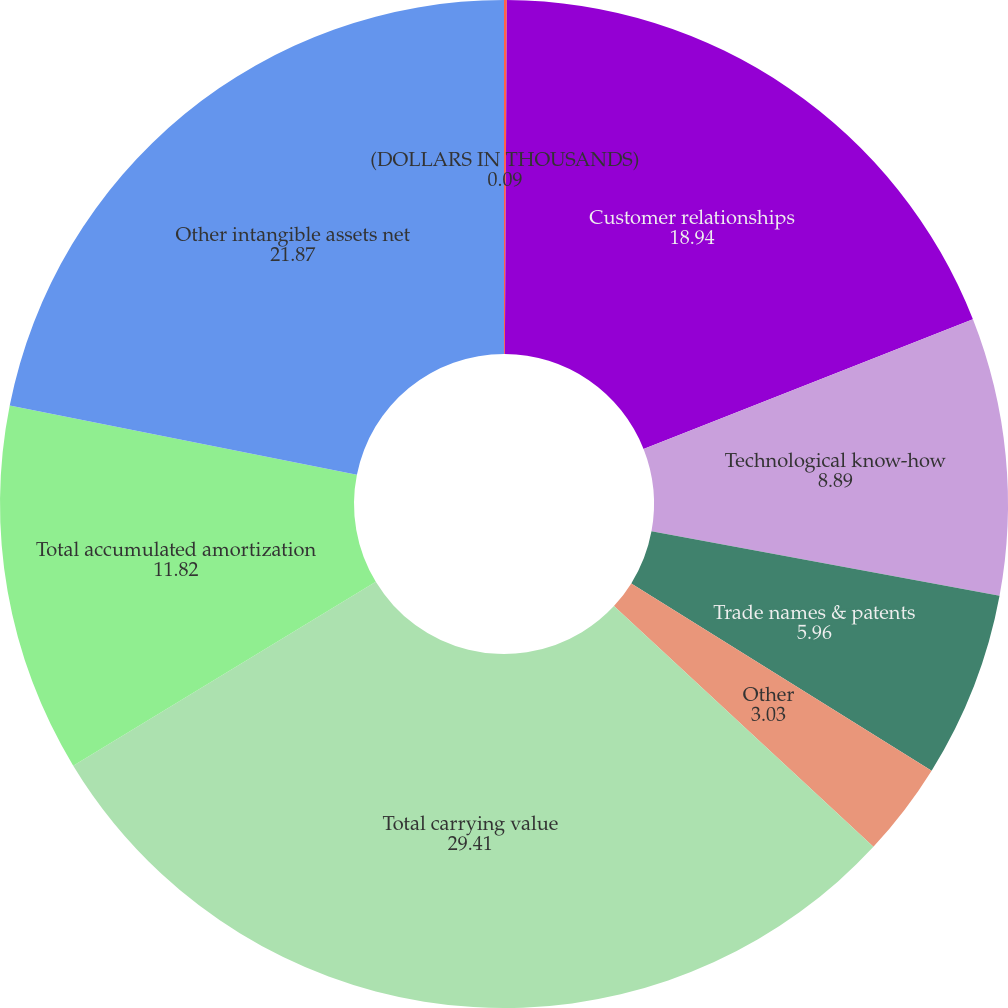Convert chart. <chart><loc_0><loc_0><loc_500><loc_500><pie_chart><fcel>(DOLLARS IN THOUSANDS)<fcel>Customer relationships<fcel>Technological know-how<fcel>Trade names & patents<fcel>Other<fcel>Total carrying value<fcel>Total accumulated amortization<fcel>Other intangible assets net<nl><fcel>0.09%<fcel>18.94%<fcel>8.89%<fcel>5.96%<fcel>3.03%<fcel>29.41%<fcel>11.82%<fcel>21.87%<nl></chart> 